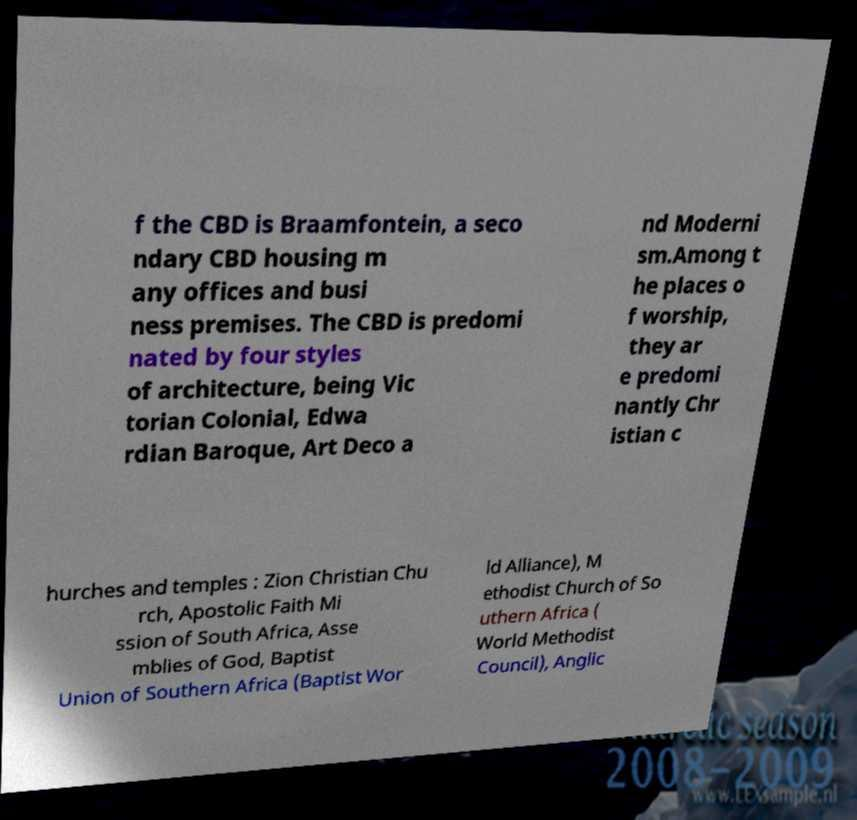Can you read and provide the text displayed in the image?This photo seems to have some interesting text. Can you extract and type it out for me? f the CBD is Braamfontein, a seco ndary CBD housing m any offices and busi ness premises. The CBD is predomi nated by four styles of architecture, being Vic torian Colonial, Edwa rdian Baroque, Art Deco a nd Moderni sm.Among t he places o f worship, they ar e predomi nantly Chr istian c hurches and temples : Zion Christian Chu rch, Apostolic Faith Mi ssion of South Africa, Asse mblies of God, Baptist Union of Southern Africa (Baptist Wor ld Alliance), M ethodist Church of So uthern Africa ( World Methodist Council), Anglic 